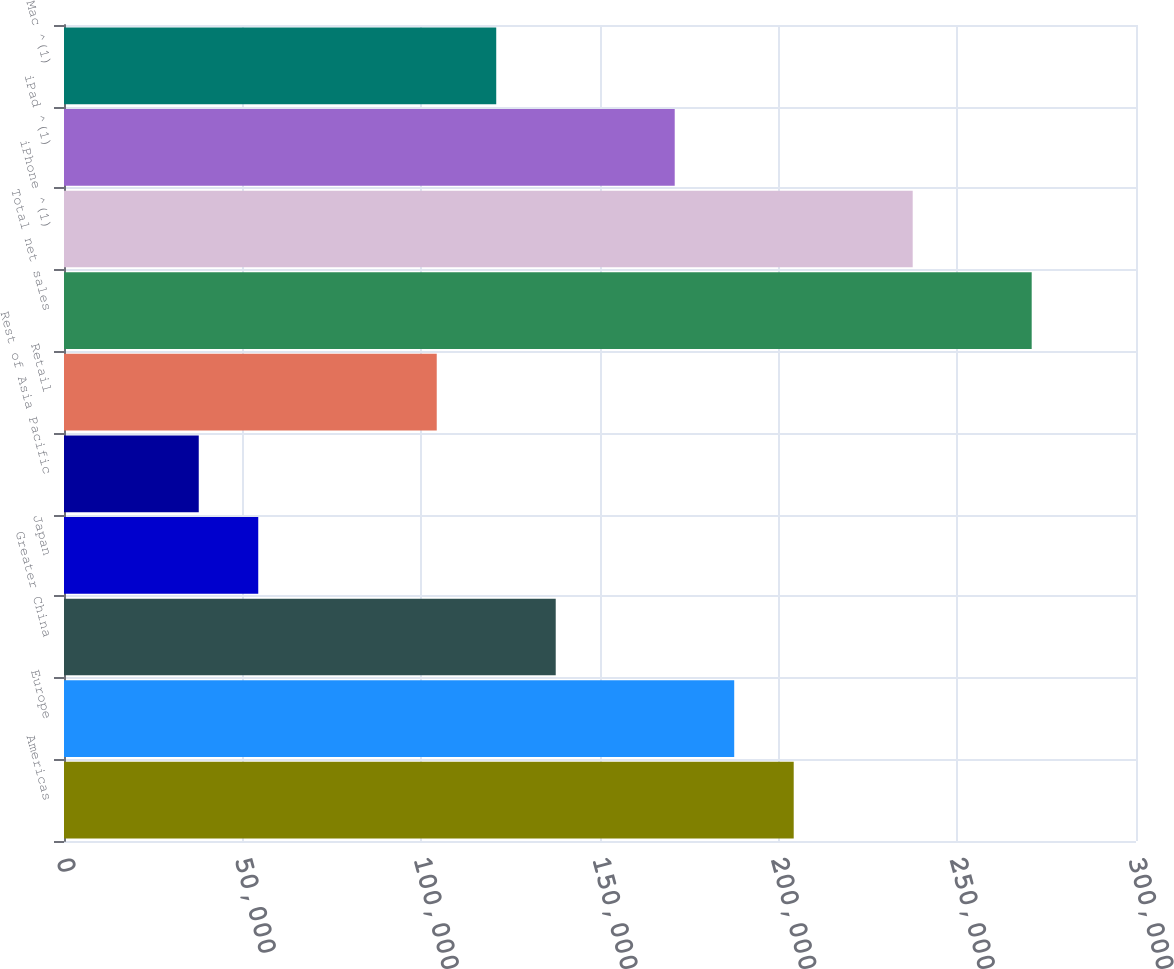Convert chart. <chart><loc_0><loc_0><loc_500><loc_500><bar_chart><fcel>Americas<fcel>Europe<fcel>Greater China<fcel>Japan<fcel>Rest of Asia Pacific<fcel>Retail<fcel>Total net sales<fcel>iPhone ^(1)<fcel>iPad ^(1)<fcel>Mac ^(1)<nl><fcel>204210<fcel>187560<fcel>137610<fcel>54360.7<fcel>37710.8<fcel>104310<fcel>270809<fcel>237510<fcel>170910<fcel>120960<nl></chart> 